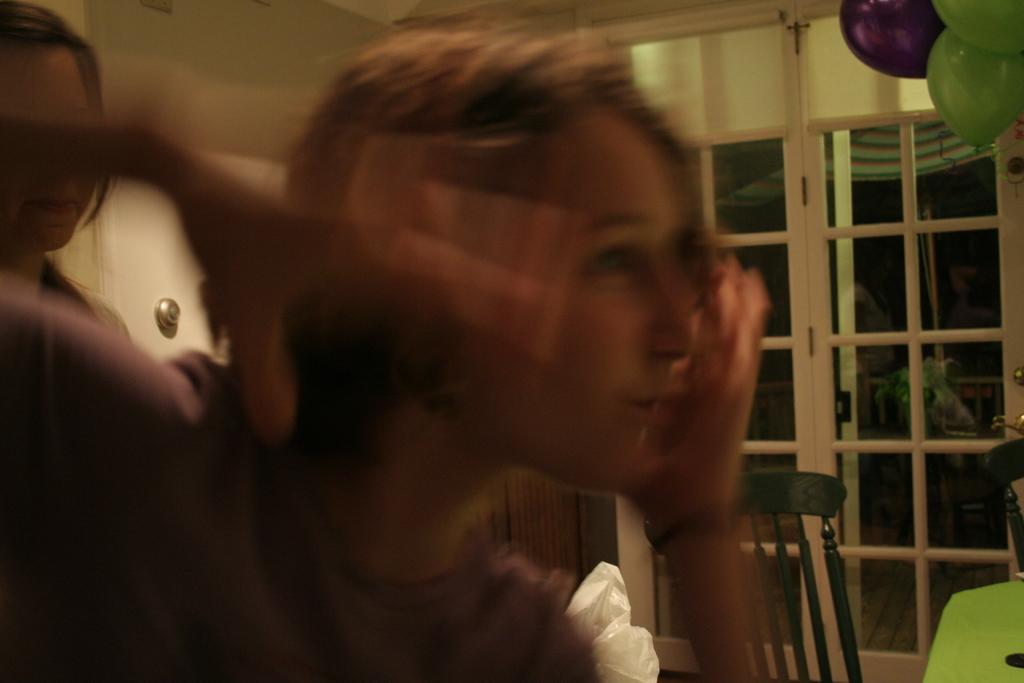Describe this image in one or two sentences. In this image we can see women. In the background there is a door, chair and wall. 